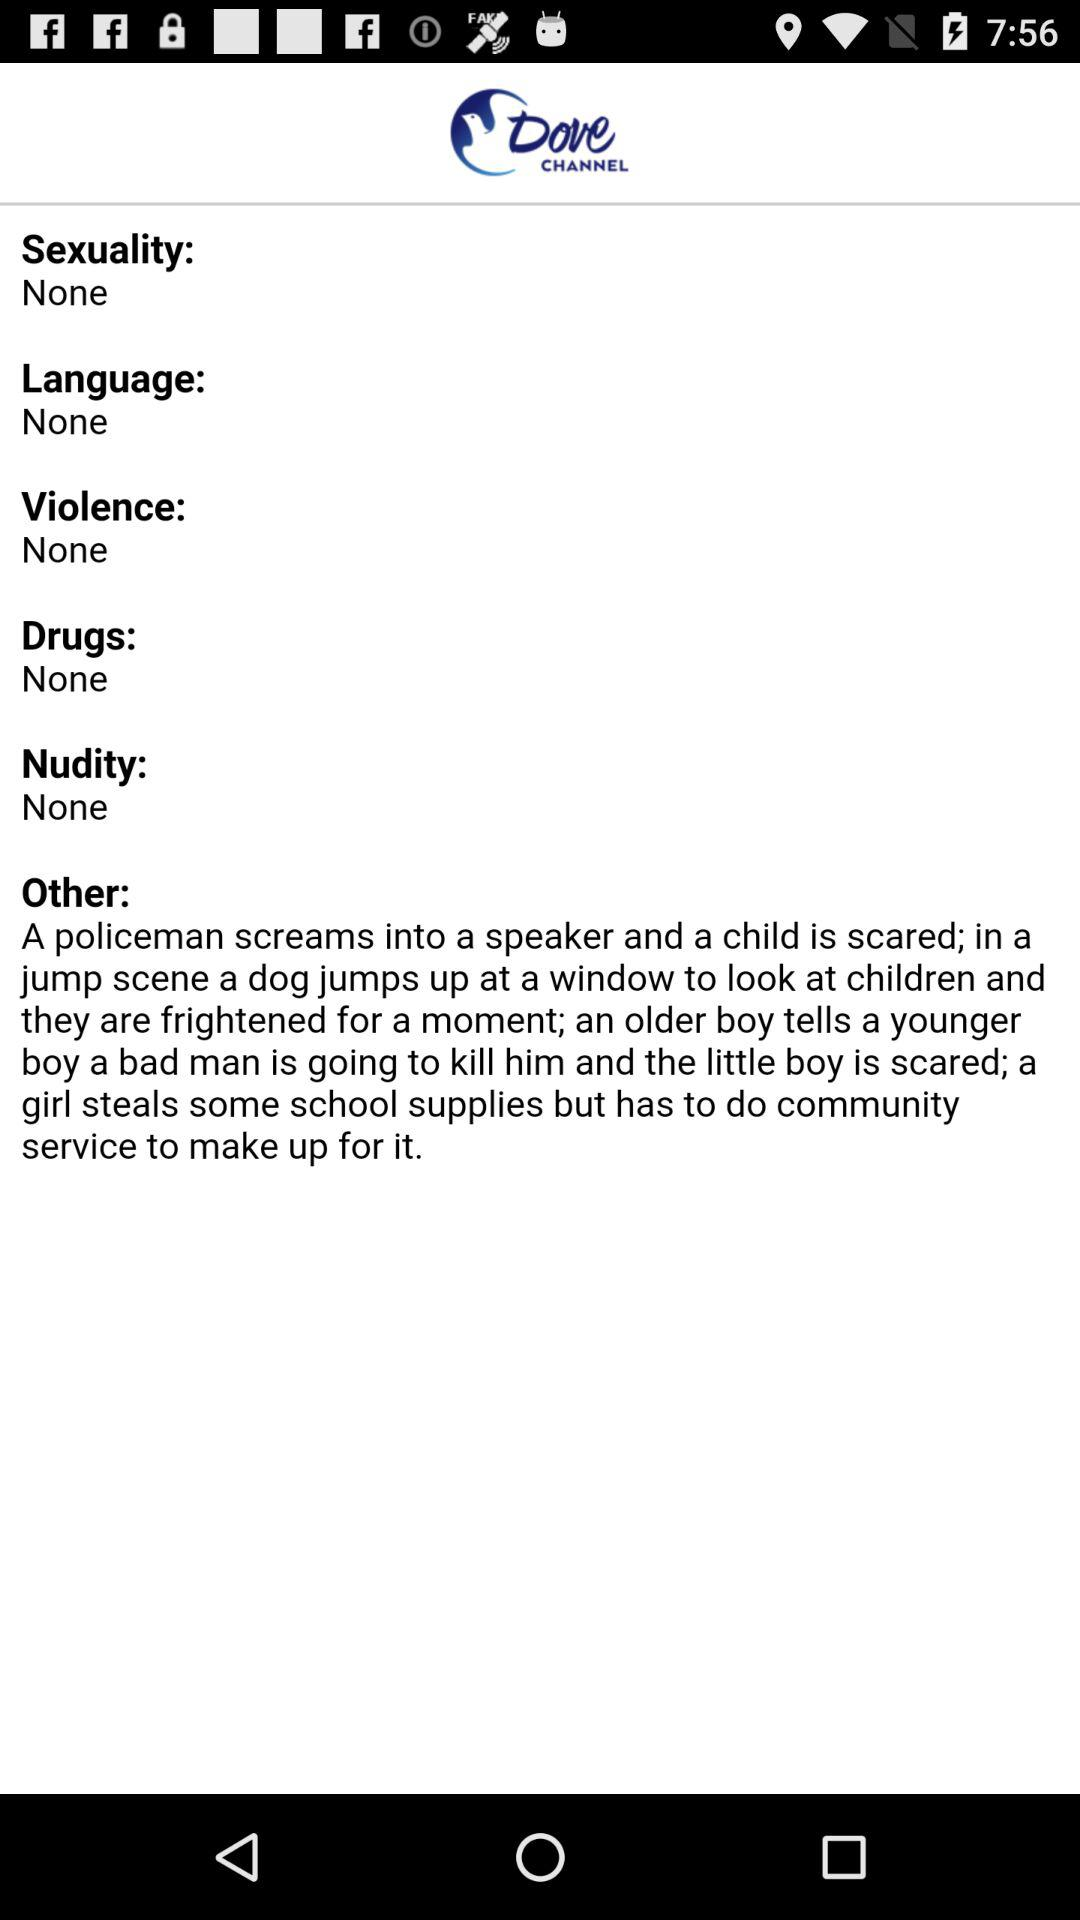What is the name of the application? The name of the application is "Dove CHANNEL". 